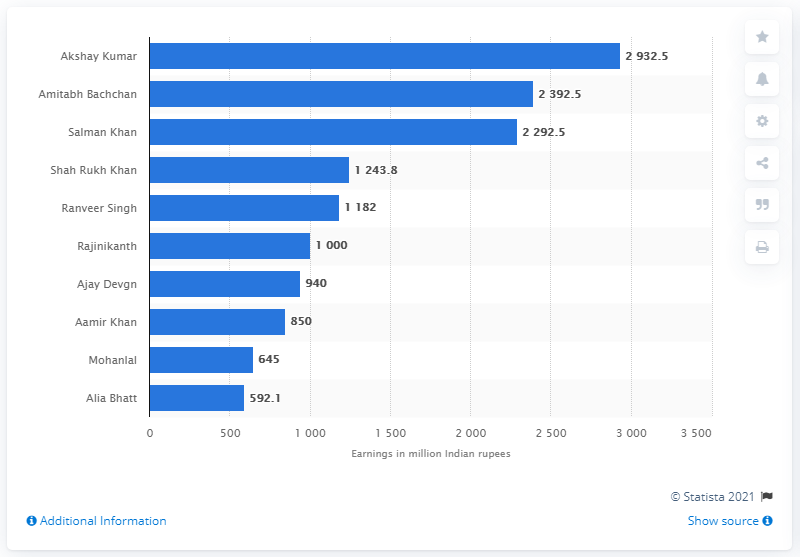Mention a couple of crucial points in this snapshot. The Forbes list featured Rajinikanth and Rajinikanth, who were joined by a Bollywood legend: Amitabh Bachchan. In 2019, Akshay Kumar was the highest paid actor in India. Rajinikanth, a Tamil superstar, has been included in Forbes' list of the world's highest paid celebrities, along with Amitabh Bachchan and Akshay Kumar. 